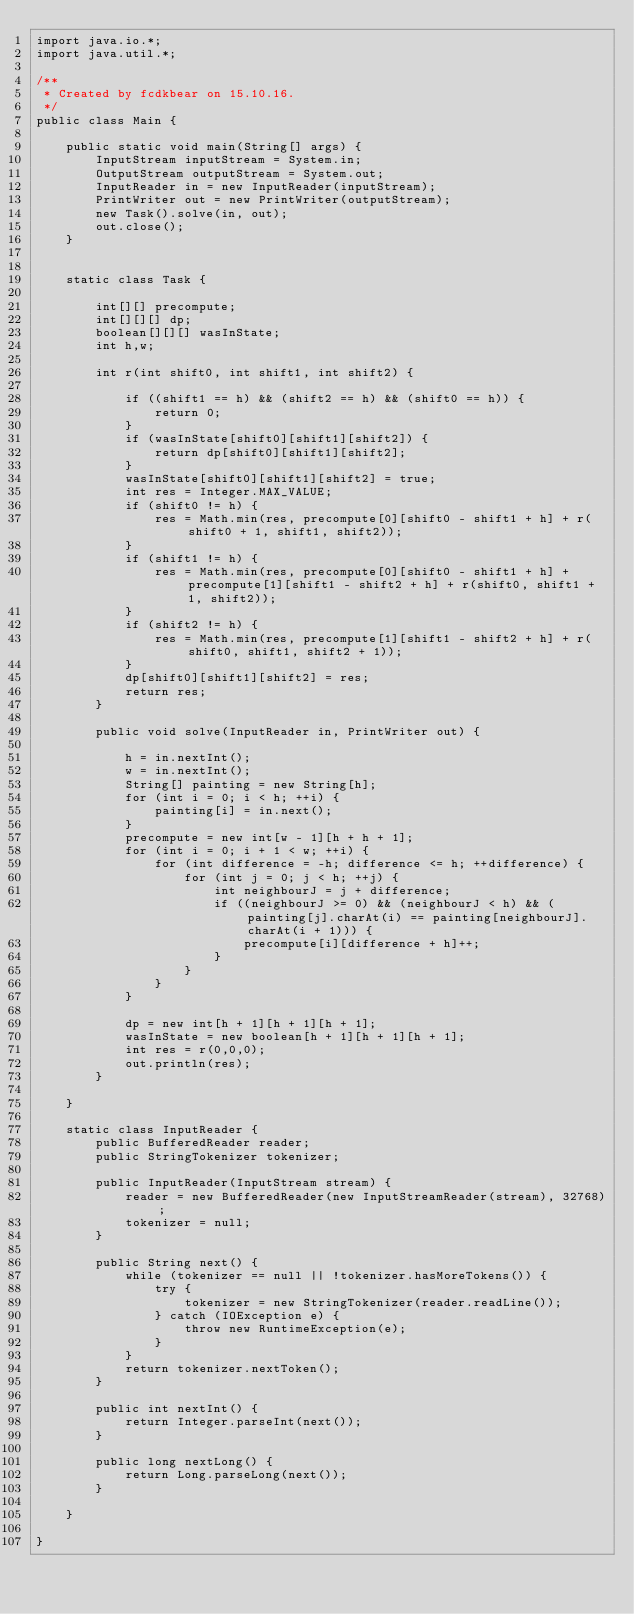Convert code to text. <code><loc_0><loc_0><loc_500><loc_500><_Java_>import java.io.*;
import java.util.*;

/**
 * Created by fcdkbear on 15.10.16.
 */
public class Main {

    public static void main(String[] args) {
        InputStream inputStream = System.in;
        OutputStream outputStream = System.out;
        InputReader in = new InputReader(inputStream);
        PrintWriter out = new PrintWriter(outputStream);
        new Task().solve(in, out);
        out.close();
    }


    static class Task {

        int[][] precompute;
        int[][][] dp;
        boolean[][][] wasInState;
        int h,w;

        int r(int shift0, int shift1, int shift2) {

            if ((shift1 == h) && (shift2 == h) && (shift0 == h)) {
                return 0;
            }
            if (wasInState[shift0][shift1][shift2]) {
                return dp[shift0][shift1][shift2];
            }
            wasInState[shift0][shift1][shift2] = true;
            int res = Integer.MAX_VALUE;
            if (shift0 != h) {
                res = Math.min(res, precompute[0][shift0 - shift1 + h] + r(shift0 + 1, shift1, shift2));
            }
            if (shift1 != h) {
                res = Math.min(res, precompute[0][shift0 - shift1 + h] + precompute[1][shift1 - shift2 + h] + r(shift0, shift1 + 1, shift2));
            }
            if (shift2 != h) {
                res = Math.min(res, precompute[1][shift1 - shift2 + h] + r(shift0, shift1, shift2 + 1));
            }
            dp[shift0][shift1][shift2] = res;
            return res;
        }

        public void solve(InputReader in, PrintWriter out) {

            h = in.nextInt();
            w = in.nextInt();
            String[] painting = new String[h];
            for (int i = 0; i < h; ++i) {
                painting[i] = in.next();
            }
            precompute = new int[w - 1][h + h + 1];
            for (int i = 0; i + 1 < w; ++i) {
                for (int difference = -h; difference <= h; ++difference) {
                    for (int j = 0; j < h; ++j) {
                        int neighbourJ = j + difference;
                        if ((neighbourJ >= 0) && (neighbourJ < h) && (painting[j].charAt(i) == painting[neighbourJ].charAt(i + 1))) {
                            precompute[i][difference + h]++;
                        }
                    }
                }
            }

            dp = new int[h + 1][h + 1][h + 1];
            wasInState = new boolean[h + 1][h + 1][h + 1];
            int res = r(0,0,0);
            out.println(res);
        }

    }

    static class InputReader {
        public BufferedReader reader;
        public StringTokenizer tokenizer;

        public InputReader(InputStream stream) {
            reader = new BufferedReader(new InputStreamReader(stream), 32768);
            tokenizer = null;
        }

        public String next() {
            while (tokenizer == null || !tokenizer.hasMoreTokens()) {
                try {
                    tokenizer = new StringTokenizer(reader.readLine());
                } catch (IOException e) {
                    throw new RuntimeException(e);
                }
            }
            return tokenizer.nextToken();
        }

        public int nextInt() {
            return Integer.parseInt(next());
        }

        public long nextLong() {
            return Long.parseLong(next());
        }

    }

}
</code> 